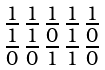<formula> <loc_0><loc_0><loc_500><loc_500>\begin{smallmatrix} 1 & 1 & 1 & 1 & 1 \\ \overline { 1 } & \overline { 1 } & \overline { 0 } & \overline { 1 } & \overline { 0 } \\ \overline { 0 } & \overline { 0 } & \overline { 1 } & \overline { 1 } & \overline { 0 } \end{smallmatrix}</formula> 